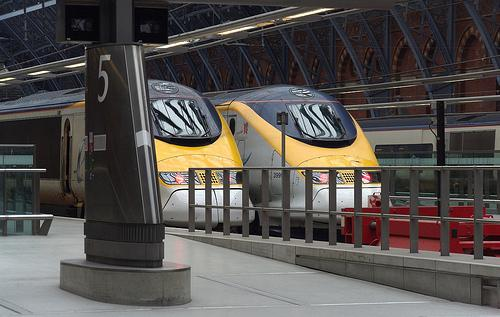Question: where are they?
Choices:
A. In a subway station.
B. On a subway train.
C. At a bus station.
D. At an airport.
Answer with the letter. Answer: A Question: what color are the trains?
Choices:
A. Red.
B. Yellow.
C. Brown.
D. Black.
Answer with the letter. Answer: B Question: who is in the picture?
Choices:
A. A jogger.
B. A skier.
C. A rowing team.
D. No one.
Answer with the letter. Answer: D Question: when was it taken?
Choices:
A. In the morning.
B. At midnight.
C. During the day.
D. Evening.
Answer with the letter. Answer: C Question: what number is on the wall?
Choices:
A. Twelve.
B. Seven.
C. Twenty three.
D. Five.
Answer with the letter. Answer: D 